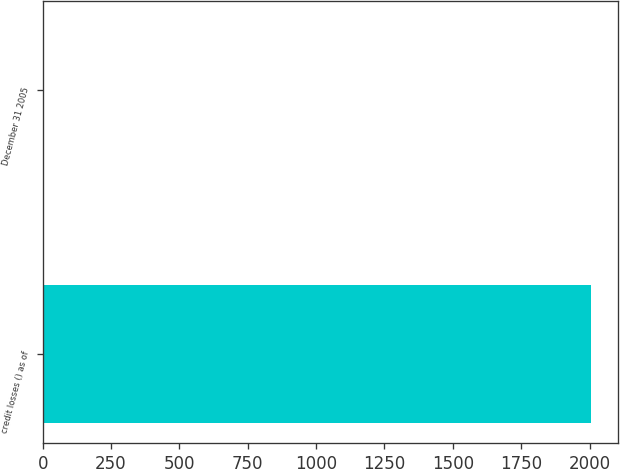Convert chart to OTSL. <chart><loc_0><loc_0><loc_500><loc_500><bar_chart><fcel>credit losses () as of<fcel>December 31 2005<nl><fcel>2005<fcel>2.6<nl></chart> 